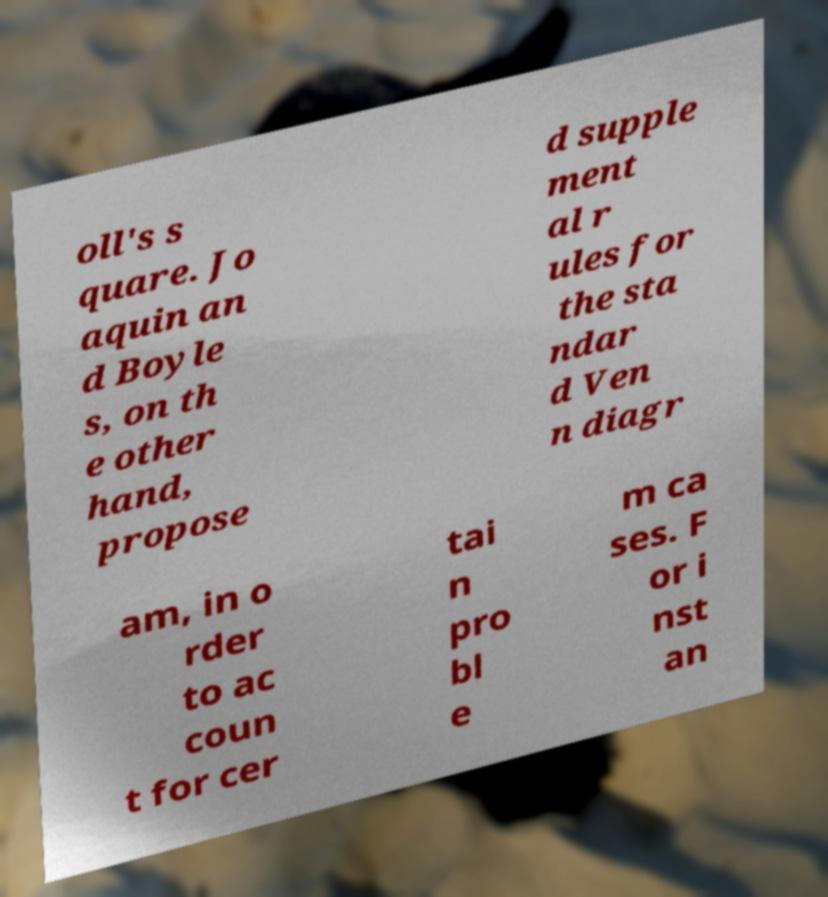Can you accurately transcribe the text from the provided image for me? oll's s quare. Jo aquin an d Boyle s, on th e other hand, propose d supple ment al r ules for the sta ndar d Ven n diagr am, in o rder to ac coun t for cer tai n pro bl e m ca ses. F or i nst an 